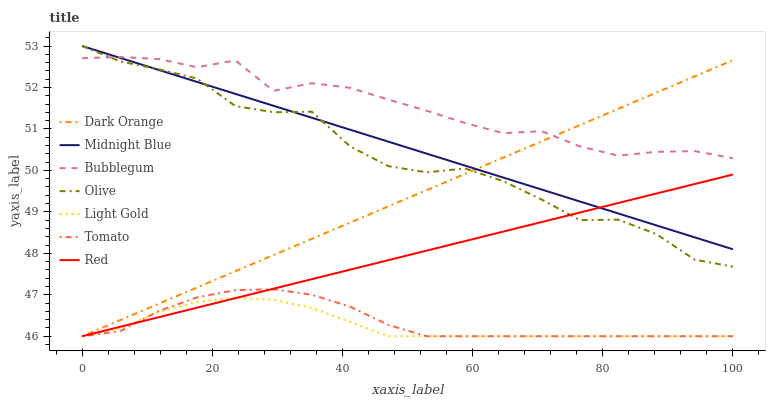Does Light Gold have the minimum area under the curve?
Answer yes or no. Yes. Does Bubblegum have the maximum area under the curve?
Answer yes or no. Yes. Does Dark Orange have the minimum area under the curve?
Answer yes or no. No. Does Dark Orange have the maximum area under the curve?
Answer yes or no. No. Is Red the smoothest?
Answer yes or no. Yes. Is Olive the roughest?
Answer yes or no. Yes. Is Dark Orange the smoothest?
Answer yes or no. No. Is Dark Orange the roughest?
Answer yes or no. No. Does Tomato have the lowest value?
Answer yes or no. Yes. Does Midnight Blue have the lowest value?
Answer yes or no. No. Does Olive have the highest value?
Answer yes or no. Yes. Does Dark Orange have the highest value?
Answer yes or no. No. Is Light Gold less than Midnight Blue?
Answer yes or no. Yes. Is Bubblegum greater than Light Gold?
Answer yes or no. Yes. Does Light Gold intersect Tomato?
Answer yes or no. Yes. Is Light Gold less than Tomato?
Answer yes or no. No. Is Light Gold greater than Tomato?
Answer yes or no. No. Does Light Gold intersect Midnight Blue?
Answer yes or no. No. 